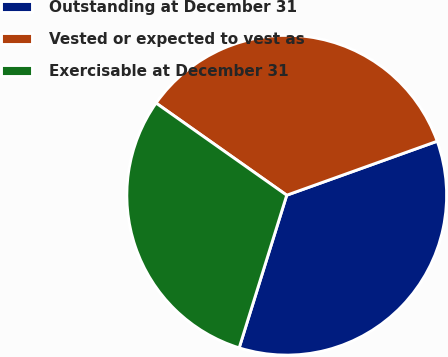Convert chart to OTSL. <chart><loc_0><loc_0><loc_500><loc_500><pie_chart><fcel>Outstanding at December 31<fcel>Vested or expected to vest as<fcel>Exercisable at December 31<nl><fcel>35.29%<fcel>34.74%<fcel>29.97%<nl></chart> 